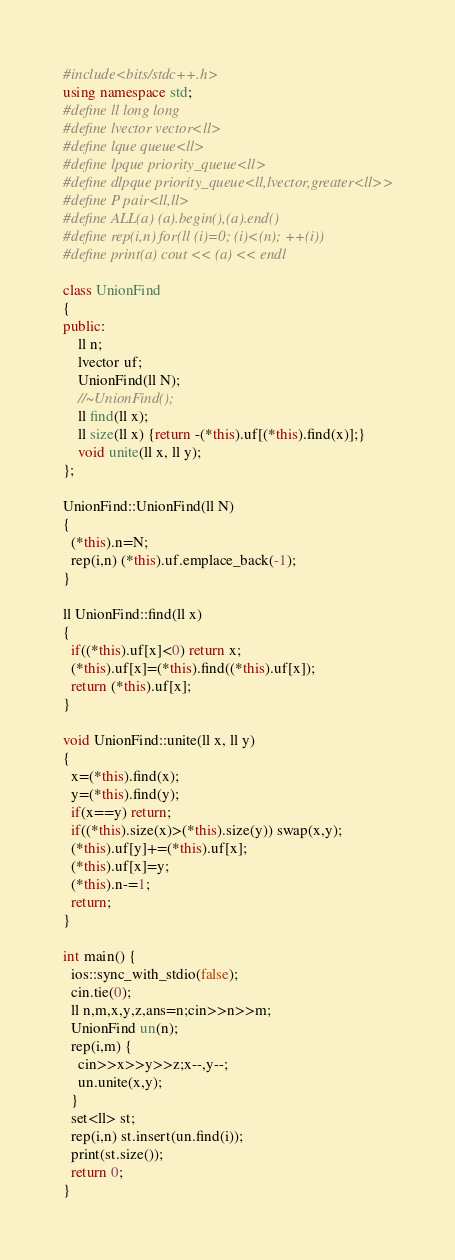<code> <loc_0><loc_0><loc_500><loc_500><_C++_>#include<bits/stdc++.h>
using namespace std;
#define ll long long
#define lvector vector<ll> 
#define lque queue<ll>
#define lpque priority_queue<ll>
#define dlpque priority_queue<ll,lvector,greater<ll>>
#define P pair<ll,ll>
#define ALL(a) (a).begin(),(a).end()
#define rep(i,n) for(ll (i)=0; (i)<(n); ++(i))
#define print(a) cout << (a) << endl

class UnionFind
{
public:
    ll n;
    lvector uf;
    UnionFind(ll N);
    //~UnionFind();
    ll find(ll x);
    ll size(ll x) {return -(*this).uf[(*this).find(x)];}
    void unite(ll x, ll y);
};

UnionFind::UnionFind(ll N)
{
  (*this).n=N;
  rep(i,n) (*this).uf.emplace_back(-1);
}

ll UnionFind::find(ll x)
{
  if((*this).uf[x]<0) return x;
  (*this).uf[x]=(*this).find((*this).uf[x]);
  return (*this).uf[x];
}

void UnionFind::unite(ll x, ll y)
{
  x=(*this).find(x);
  y=(*this).find(y);
  if(x==y) return;
  if((*this).size(x)>(*this).size(y)) swap(x,y);
  (*this).uf[y]+=(*this).uf[x];
  (*this).uf[x]=y;
  (*this).n-=1;
  return;
}

int main() {
  ios::sync_with_stdio(false);
  cin.tie(0);
  ll n,m,x,y,z,ans=n;cin>>n>>m;
  UnionFind un(n);
  rep(i,m) {
    cin>>x>>y>>z;x--,y--;
    un.unite(x,y);
  }
  set<ll> st;
  rep(i,n) st.insert(un.find(i));
  print(st.size());
  return 0;
}</code> 